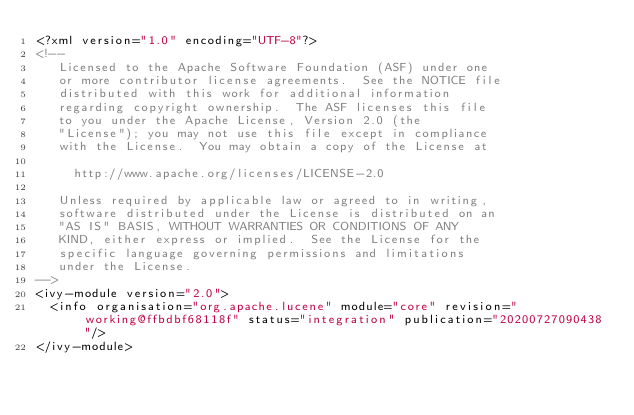<code> <loc_0><loc_0><loc_500><loc_500><_XML_><?xml version="1.0" encoding="UTF-8"?>
<!--
   Licensed to the Apache Software Foundation (ASF) under one
   or more contributor license agreements.  See the NOTICE file
   distributed with this work for additional information
   regarding copyright ownership.  The ASF licenses this file
   to you under the Apache License, Version 2.0 (the
   "License"); you may not use this file except in compliance
   with the License.  You may obtain a copy of the License at

     http://www.apache.org/licenses/LICENSE-2.0

   Unless required by applicable law or agreed to in writing,
   software distributed under the License is distributed on an
   "AS IS" BASIS, WITHOUT WARRANTIES OR CONDITIONS OF ANY
   KIND, either express or implied.  See the License for the
   specific language governing permissions and limitations
   under the License.    
-->
<ivy-module version="2.0">
  <info organisation="org.apache.lucene" module="core" revision="working@ffbdbf68118f" status="integration" publication="20200727090438"/>
</ivy-module>
</code> 